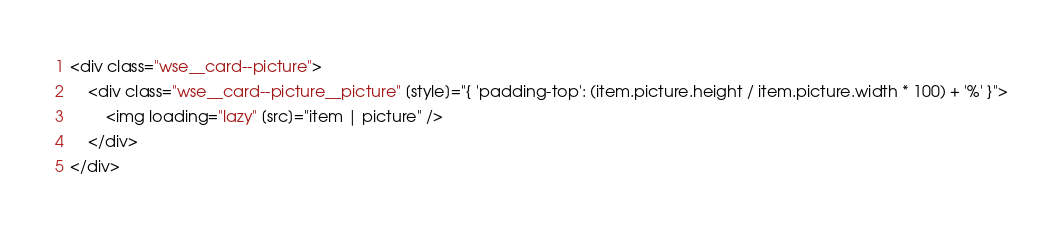Convert code to text. <code><loc_0><loc_0><loc_500><loc_500><_HTML_><div class="wse__card--picture">
	<div class="wse__card--picture__picture" [style]="{ 'padding-top': (item.picture.height / item.picture.width * 100) + '%' }">
		<img loading="lazy" [src]="item | picture" />
	</div>
</div>
</code> 